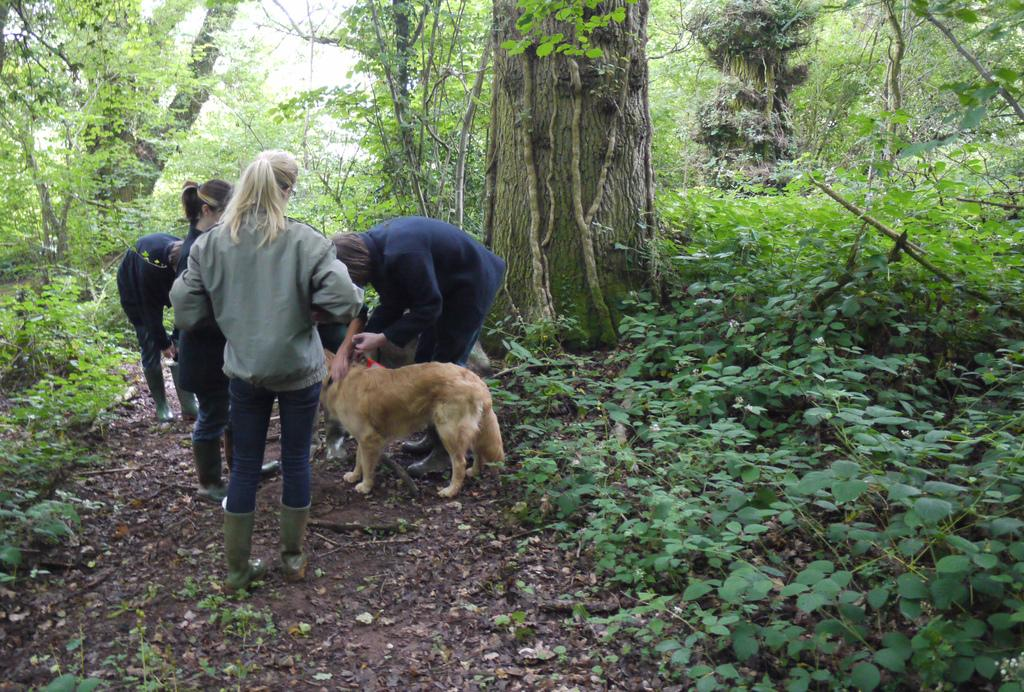Who or what can be seen in the image? There are people and a dog in the image. Where are the people and the dog located in the image? The dog and people are on the left side of the image. What can be observed in the surroundings of the image? There is greenery around the area of the image. What is the purpose of the cemetery in the image? There is no cemetery present in the image. 